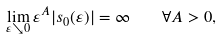Convert formula to latex. <formula><loc_0><loc_0><loc_500><loc_500>\lim _ { \varepsilon \searrow 0 } \varepsilon ^ { A } | s _ { 0 } ( \varepsilon ) | = \infty \quad \forall A > 0 ,</formula> 